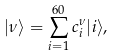<formula> <loc_0><loc_0><loc_500><loc_500>| \nu \rangle = \sum _ { i = 1 } ^ { 6 0 } c _ { i } ^ { \nu } | i \rangle ,</formula> 